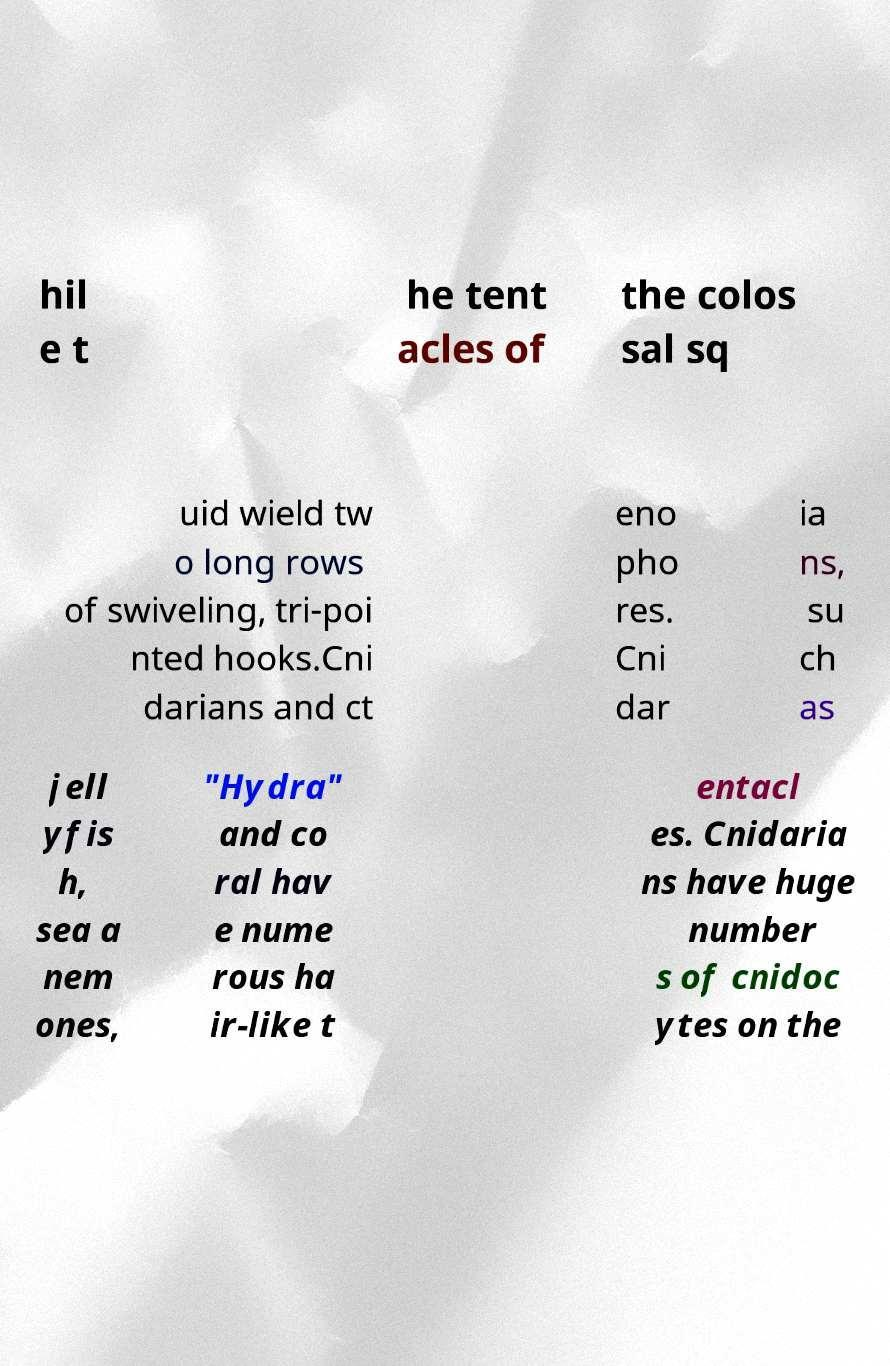What messages or text are displayed in this image? I need them in a readable, typed format. hil e t he tent acles of the colos sal sq uid wield tw o long rows of swiveling, tri-poi nted hooks.Cni darians and ct eno pho res. Cni dar ia ns, su ch as jell yfis h, sea a nem ones, "Hydra" and co ral hav e nume rous ha ir-like t entacl es. Cnidaria ns have huge number s of cnidoc ytes on the 